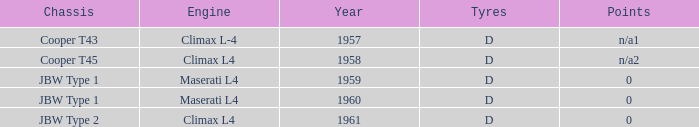What company built the chassis for a year later than 1959 and a climax l4 engine? JBW Type 2. 